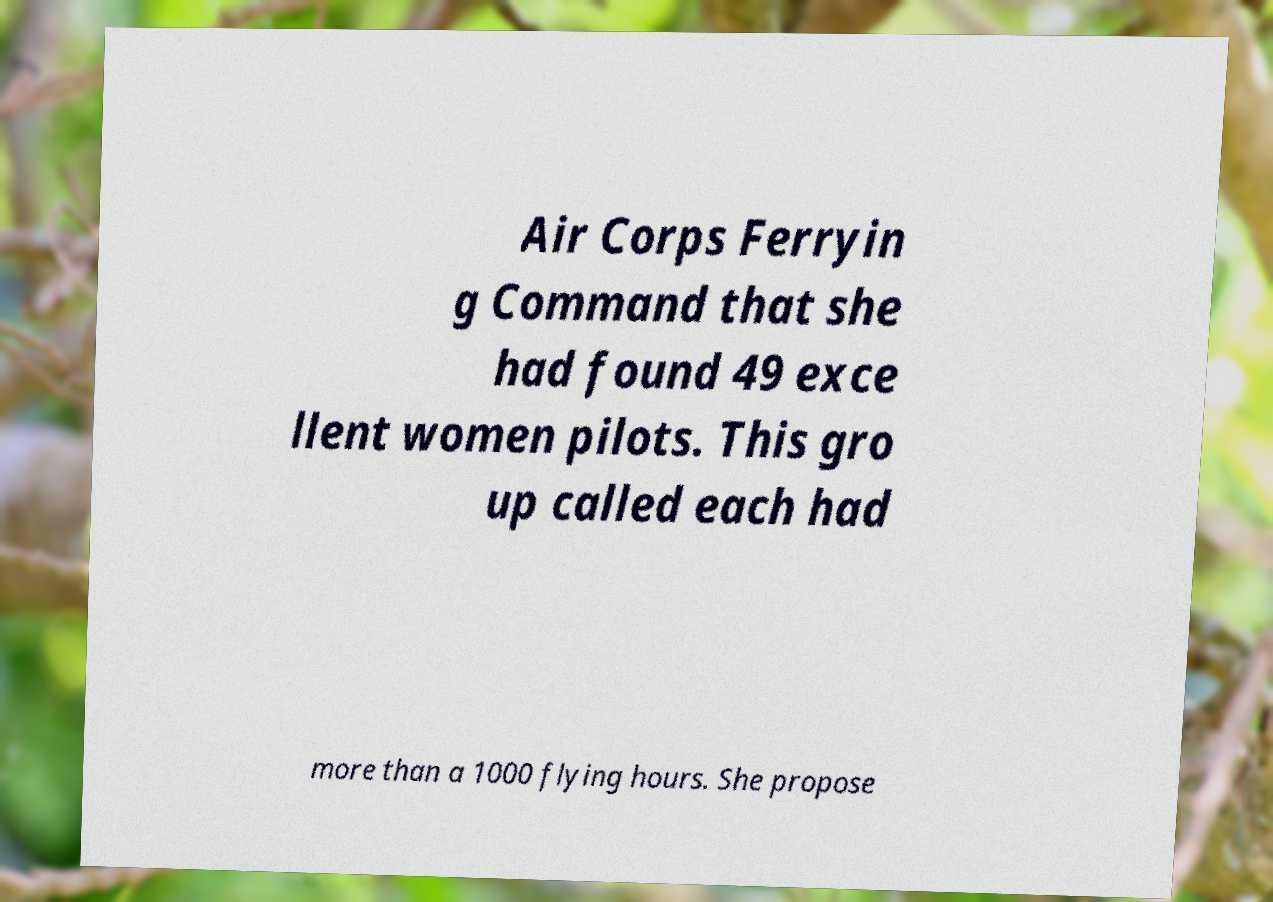Please read and relay the text visible in this image. What does it say? Air Corps Ferryin g Command that she had found 49 exce llent women pilots. This gro up called each had more than a 1000 flying hours. She propose 